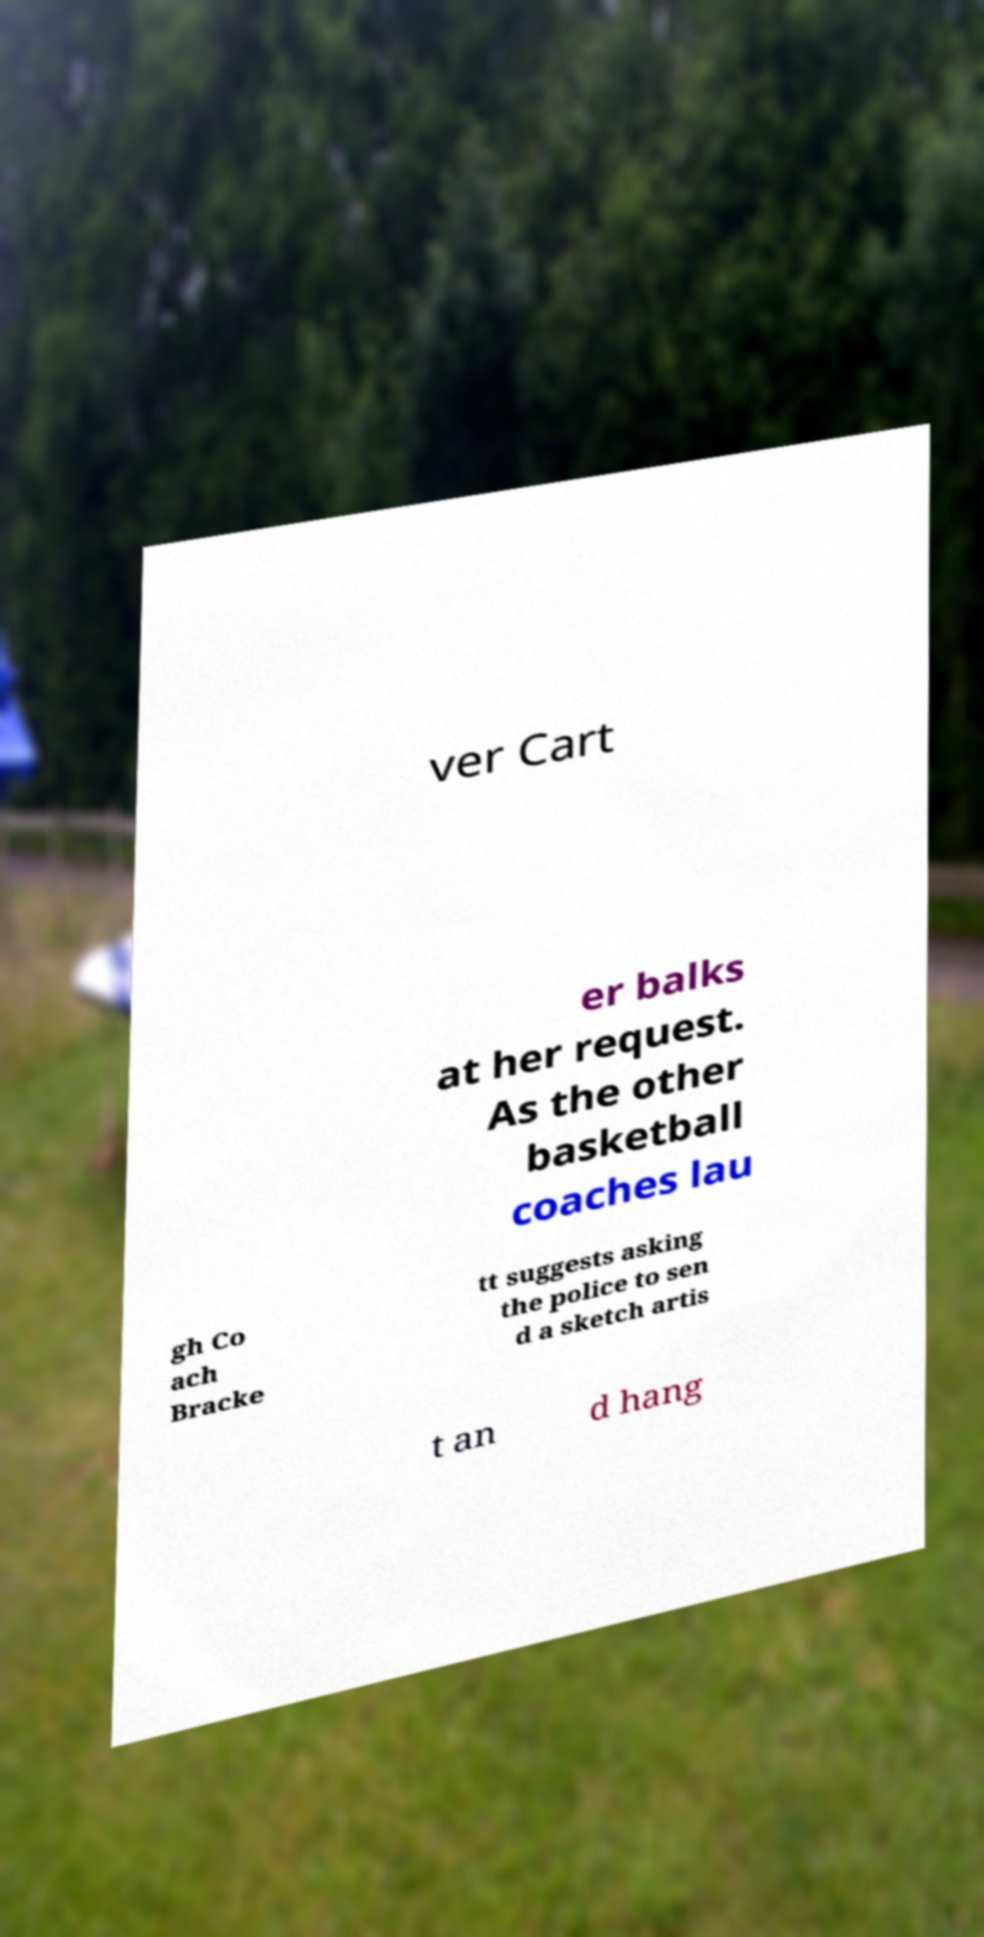For documentation purposes, I need the text within this image transcribed. Could you provide that? ver Cart er balks at her request. As the other basketball coaches lau gh Co ach Bracke tt suggests asking the police to sen d a sketch artis t an d hang 